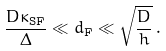Convert formula to latex. <formula><loc_0><loc_0><loc_500><loc_500>\frac { D \kappa _ { \text {SF} } } { \Delta } \ll d _ { \text {F} } \ll \sqrt { \frac { D } { h } } \, .</formula> 